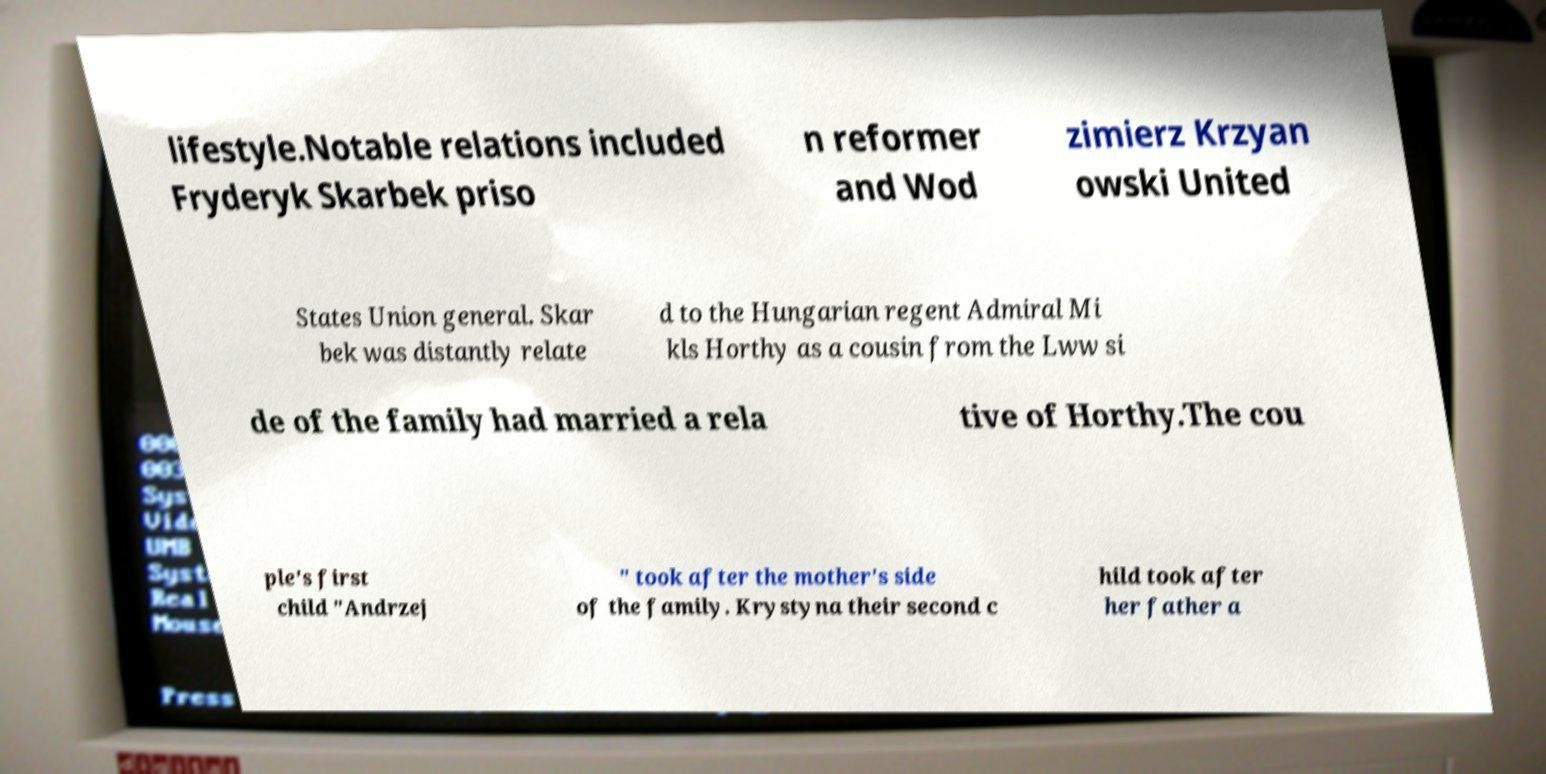Please read and relay the text visible in this image. What does it say? lifestyle.Notable relations included Fryderyk Skarbek priso n reformer and Wod zimierz Krzyan owski United States Union general. Skar bek was distantly relate d to the Hungarian regent Admiral Mi kls Horthy as a cousin from the Lww si de of the family had married a rela tive of Horthy.The cou ple's first child "Andrzej " took after the mother's side of the family. Krystyna their second c hild took after her father a 